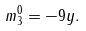<formula> <loc_0><loc_0><loc_500><loc_500>m _ { 3 } ^ { 0 } = - 9 y .</formula> 